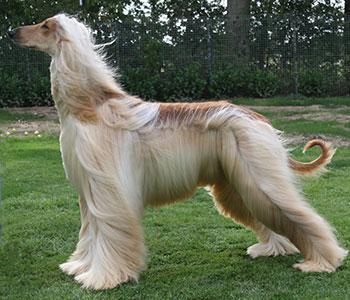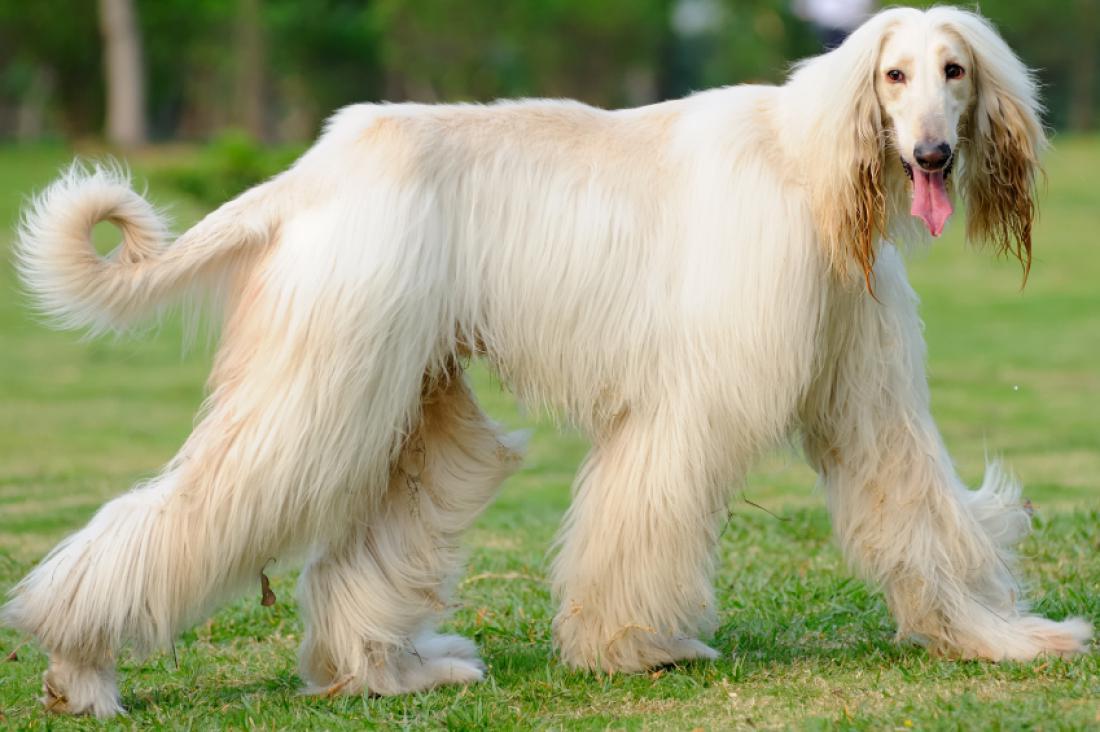The first image is the image on the left, the second image is the image on the right. Evaluate the accuracy of this statement regarding the images: "All dogs shown have mostly gray fur.". Is it true? Answer yes or no. No. 